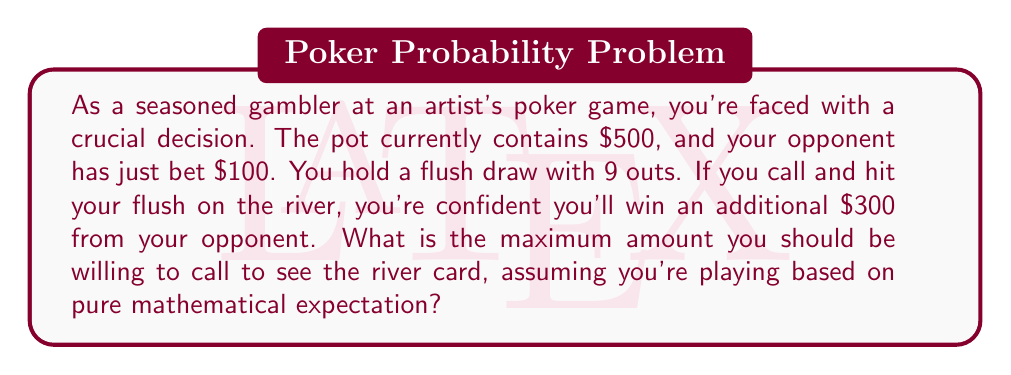Show me your answer to this math problem. Let's approach this step-by-step:

1) First, we need to calculate the probability of hitting our flush on the river:
   - We have 9 outs out of 47 unseen cards (52 - 5 on board)
   - Probability = $\frac{9}{47} \approx 0.1915$ or 19.15%

2) Now, let's calculate the Expected Value (EV) of calling:
   - If we hit (19.15% of the time), we win the current pot ($500), the bet ($100), and the additional $300
   - If we miss (80.85% of the time), we lose our call amount (let's call it $x)

   $$ EV = 0.1915(500 + 100 + 300) - 0.8085x $$
   $$ EV = 172.35 - 0.8085x $$

3) To find the maximum call amount, we set EV to 0 and solve for x:
   $$ 0 = 172.35 - 0.8085x $$
   $$ 0.8085x = 172.35 $$
   $$ x = \frac{172.35}{0.8085} \approx 213.17 $$

4) Therefore, the maximum amount we should call is $213.17.

5) To verify, let's calculate the pot odds:
   - We're getting $600 : $213.17
   - Simplified, that's about 2.81 : 1
   - Converting to a percentage: $\frac{1}{2.81 + 1} \approx 0.1915$ or 19.15%

This matches our calculated probability of hitting the flush, confirming our calculation.
Answer: The maximum amount you should be willing to call is $213.17. 